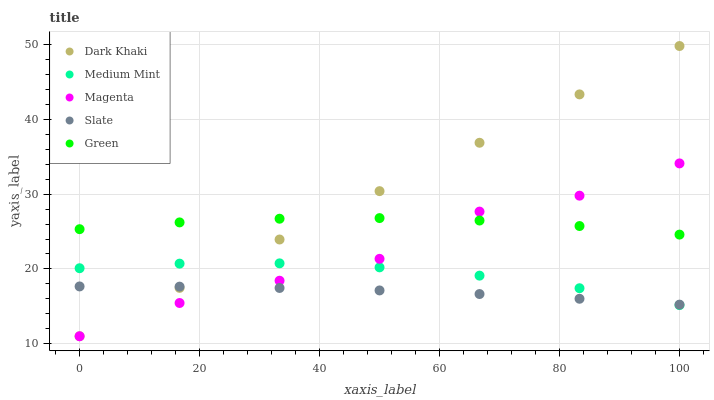Does Slate have the minimum area under the curve?
Answer yes or no. Yes. Does Dark Khaki have the maximum area under the curve?
Answer yes or no. Yes. Does Medium Mint have the minimum area under the curve?
Answer yes or no. No. Does Medium Mint have the maximum area under the curve?
Answer yes or no. No. Is Dark Khaki the smoothest?
Answer yes or no. Yes. Is Magenta the roughest?
Answer yes or no. Yes. Is Medium Mint the smoothest?
Answer yes or no. No. Is Medium Mint the roughest?
Answer yes or no. No. Does Dark Khaki have the lowest value?
Answer yes or no. Yes. Does Medium Mint have the lowest value?
Answer yes or no. No. Does Dark Khaki have the highest value?
Answer yes or no. Yes. Does Medium Mint have the highest value?
Answer yes or no. No. Is Slate less than Green?
Answer yes or no. Yes. Is Green greater than Slate?
Answer yes or no. Yes. Does Green intersect Magenta?
Answer yes or no. Yes. Is Green less than Magenta?
Answer yes or no. No. Is Green greater than Magenta?
Answer yes or no. No. Does Slate intersect Green?
Answer yes or no. No. 